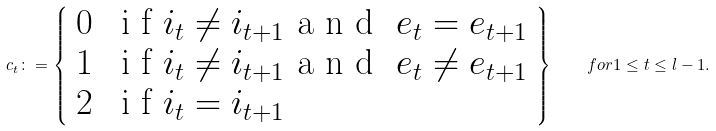Convert formula to latex. <formula><loc_0><loc_0><loc_500><loc_500>c _ { t } \colon = \left \{ \begin{array} { l l } 0 & $ i f $ i _ { t } \neq i _ { t + 1 } $ a n d \/ $ e _ { t } = e _ { t + 1 } \\ 1 & $ i f $ i _ { t } \neq i _ { t + 1 } $ a n d \/ $ e _ { t } \neq e _ { t + 1 } \\ 2 & $ i f $ i _ { t } = i _ { t + 1 } \end{array} \right \} \quad f o r \/ 1 \leq t \leq l - 1 .</formula> 